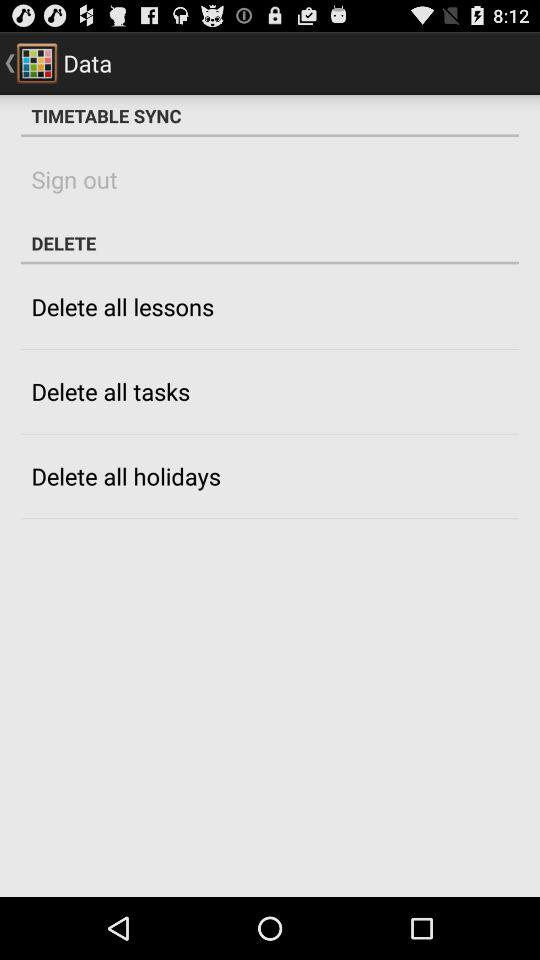What is the name of the application? The name of the application is "Timetable". 